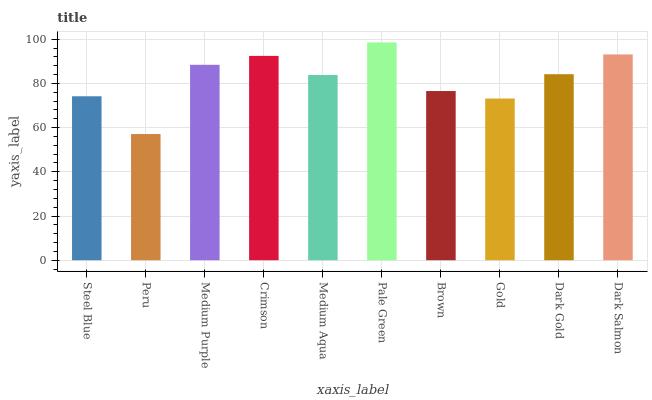Is Medium Purple the minimum?
Answer yes or no. No. Is Medium Purple the maximum?
Answer yes or no. No. Is Medium Purple greater than Peru?
Answer yes or no. Yes. Is Peru less than Medium Purple?
Answer yes or no. Yes. Is Peru greater than Medium Purple?
Answer yes or no. No. Is Medium Purple less than Peru?
Answer yes or no. No. Is Dark Gold the high median?
Answer yes or no. Yes. Is Medium Aqua the low median?
Answer yes or no. Yes. Is Steel Blue the high median?
Answer yes or no. No. Is Medium Purple the low median?
Answer yes or no. No. 